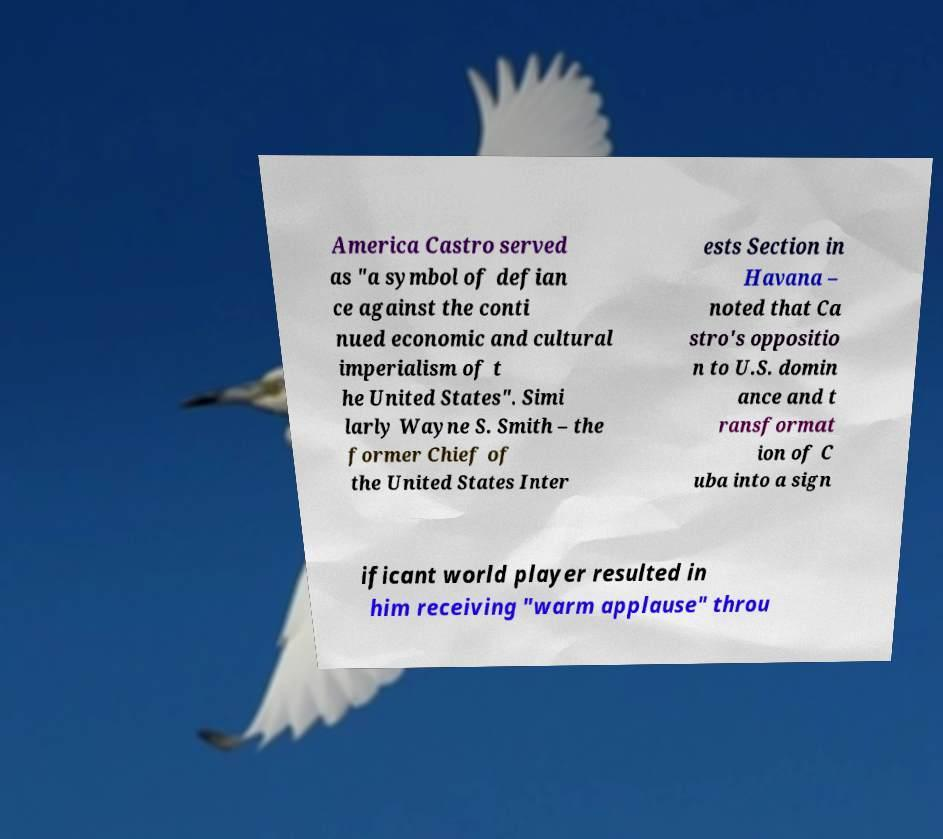I need the written content from this picture converted into text. Can you do that? America Castro served as "a symbol of defian ce against the conti nued economic and cultural imperialism of t he United States". Simi larly Wayne S. Smith – the former Chief of the United States Inter ests Section in Havana – noted that Ca stro's oppositio n to U.S. domin ance and t ransformat ion of C uba into a sign ificant world player resulted in him receiving "warm applause" throu 